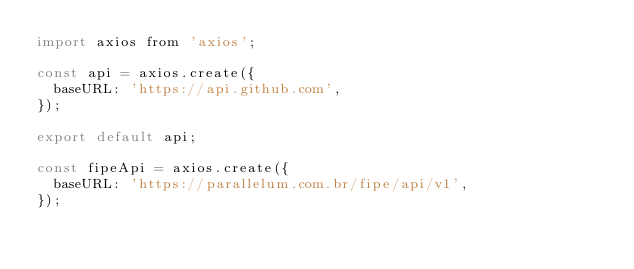<code> <loc_0><loc_0><loc_500><loc_500><_JavaScript_>import axios from 'axios';

const api = axios.create({
  baseURL: 'https://api.github.com',
});

export default api;

const fipeApi = axios.create({
  baseURL: 'https://parallelum.com.br/fipe/api/v1',
});
</code> 